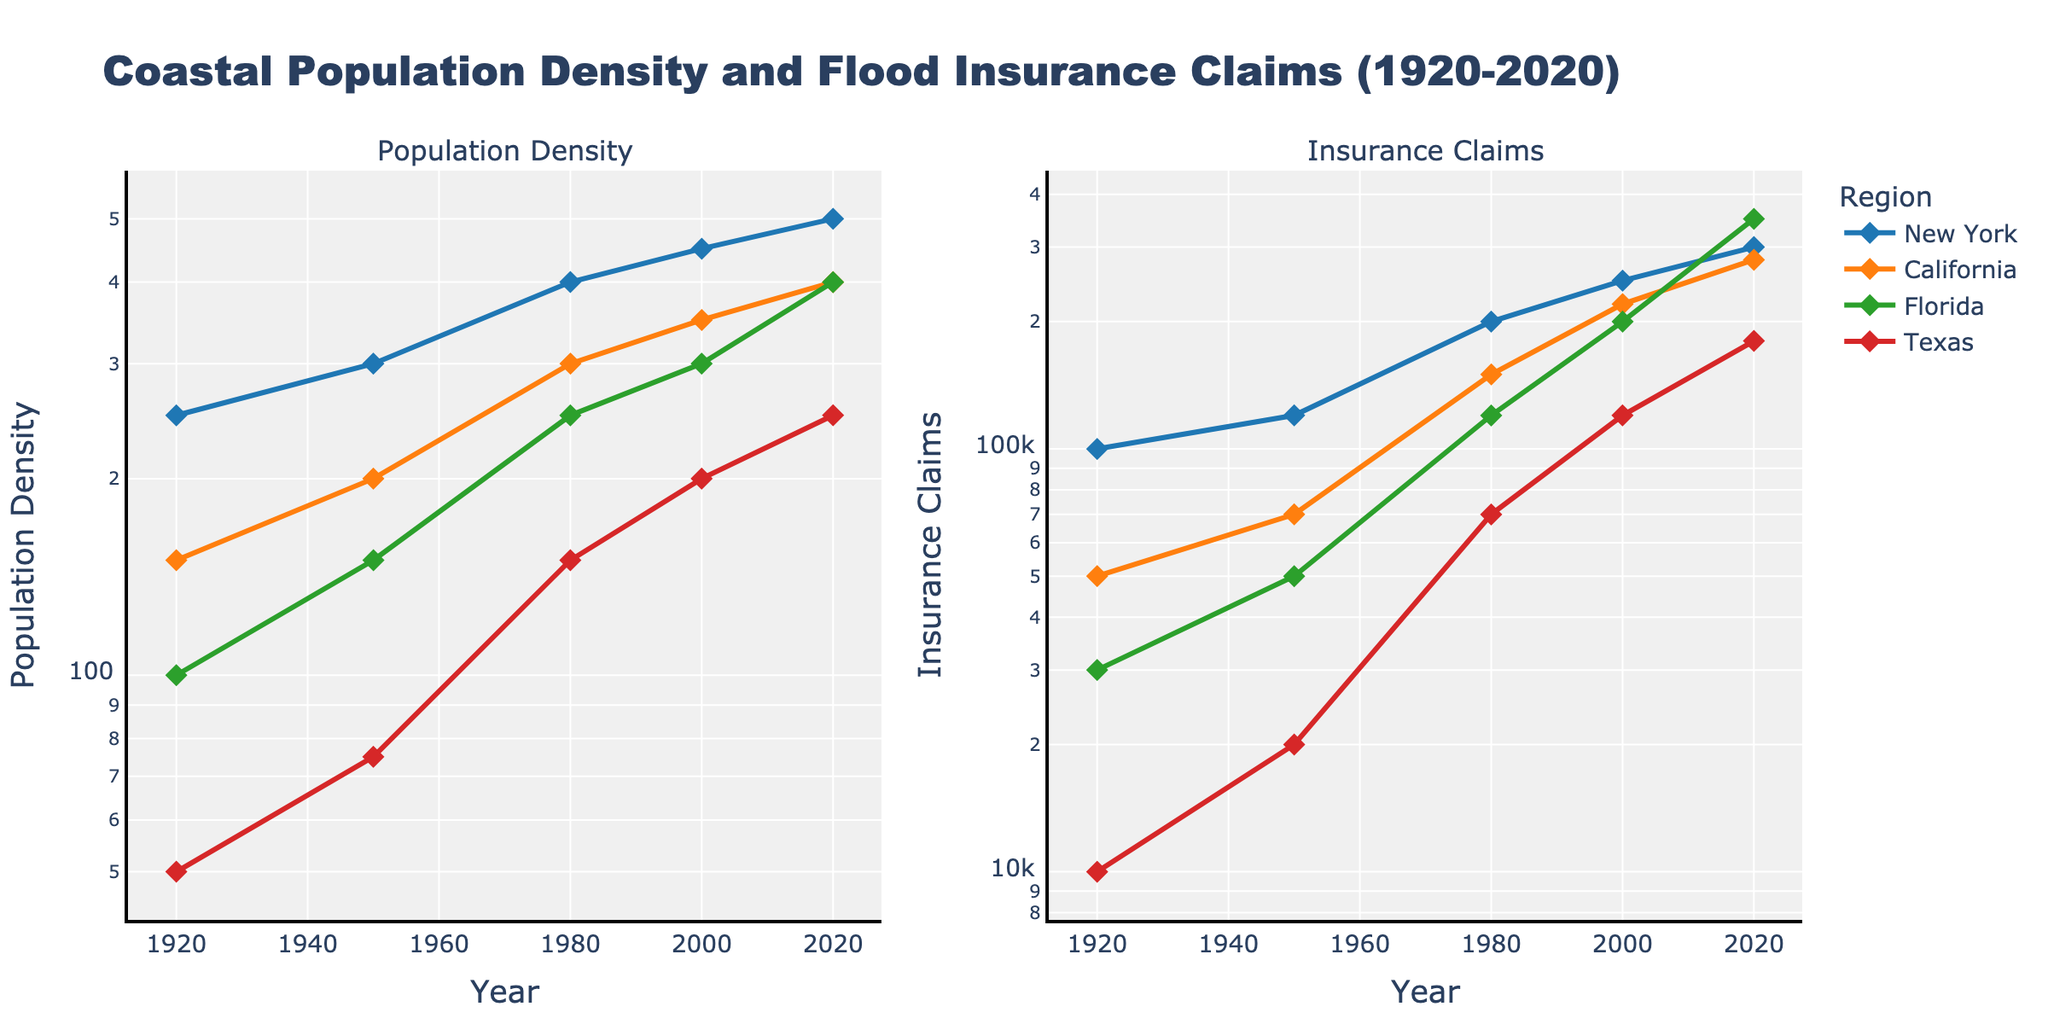What is the title of the figure? The title of the figure is found at the top and describes the overall content.
Answer: Coastal Population Density and Flood Insurance Claims (1920-2020) Which region had the highest population density in 2020? By looking at the year 2020 on the Population Density subplot, the highest point is for either Florida or California.
Answer: Florida How do the insurance claims in Texas in 1950 compare with those in New York in 1950? Locate the data points for both regions in 1950 on the Insurance Claims subplot and compare the values. Insurance claims in New York were 120,000, while in Texas they were 20,000.
Answer: New York > Texas What is the general trend in population density for California from 1920 to 2020? Observe the line for California on the Population Density subplot from 1920 to 2020, which generally climbs upwards, indicating an increase.
Answer: Increasing Which year saw the largest increase in insurance claims in Florida when compared to the previous recorded year? Compare the values for Florida across years on the Insurance Claims subplot. The largest increase occurred from 2000 (200,000) to 2020 (350,000).
Answer: 2020 Compare the population density of New York and Texas in 2000. Locate the year 2000 on the Population Density subplot and compare the points for New York (450) and Texas (200).
Answer: New York > Texas What is the relationship between population density and insurance claims for Florida over the years? Observe both subplots for Florida to see how the trends align. Both population density and insurance claims generally increase over the years.
Answer: Positive correlation In which year did New York have an insurance claim value closest to 300,000? Check the Insurance Claims subplot for New York to find the year approaching 300,000 the closest. It is 2020.
Answer: 2020 What was the population density of California in 1950, and how does it compare to its value in 1980? Locate the points for California in 1950 and 1980 on the Population Density subplot. The density increased from 200 to 300.
Answer: Increased by 100 Which region had the smallest increase in population density from 1920 to 2020? Compare the differences in Population Density between 1920 and 2020 for all regions. Texas increased from 50 to 250, which is the smallest increment compared to other regions.
Answer: Texas 